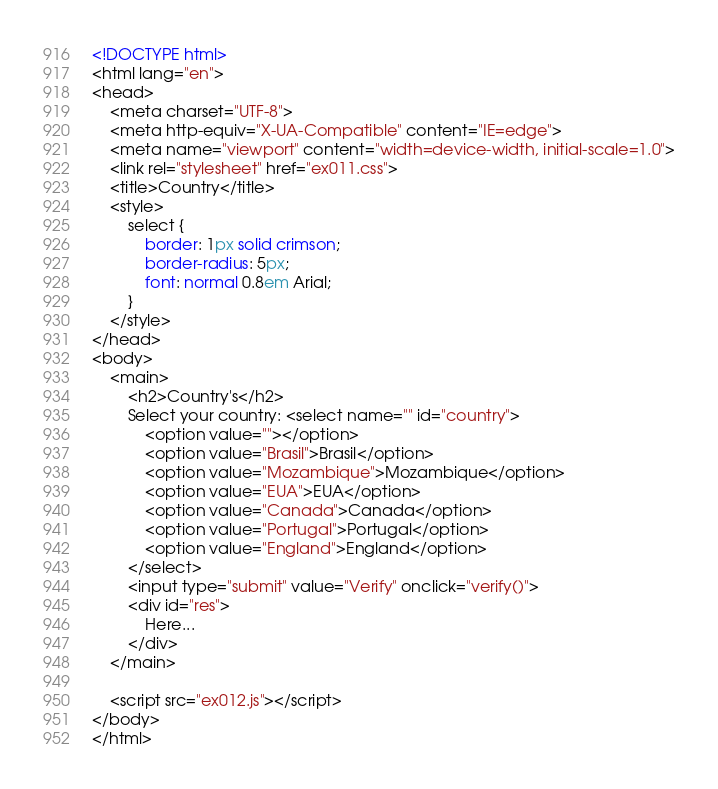Convert code to text. <code><loc_0><loc_0><loc_500><loc_500><_HTML_><!DOCTYPE html>
<html lang="en">
<head>
    <meta charset="UTF-8">
    <meta http-equiv="X-UA-Compatible" content="IE=edge">
    <meta name="viewport" content="width=device-width, initial-scale=1.0">
    <link rel="stylesheet" href="ex011.css">
    <title>Country</title>
    <style>
        select {
            border: 1px solid crimson;
            border-radius: 5px;
            font: normal 0.8em Arial;
        }
    </style>
</head>
<body>
    <main>
        <h2>Country's</h2>
        Select your country: <select name="" id="country">
            <option value=""></option>
            <option value="Brasil">Brasil</option>
            <option value="Mozambique">Mozambique</option>
            <option value="EUA">EUA</option>
            <option value="Canada">Canada</option>
            <option value="Portugal">Portugal</option>
            <option value="England">England</option>
        </select>
        <input type="submit" value="Verify" onclick="verify()">
        <div id="res">
            Here...
        </div>
    </main>

    <script src="ex012.js"></script>
</body>
</html></code> 